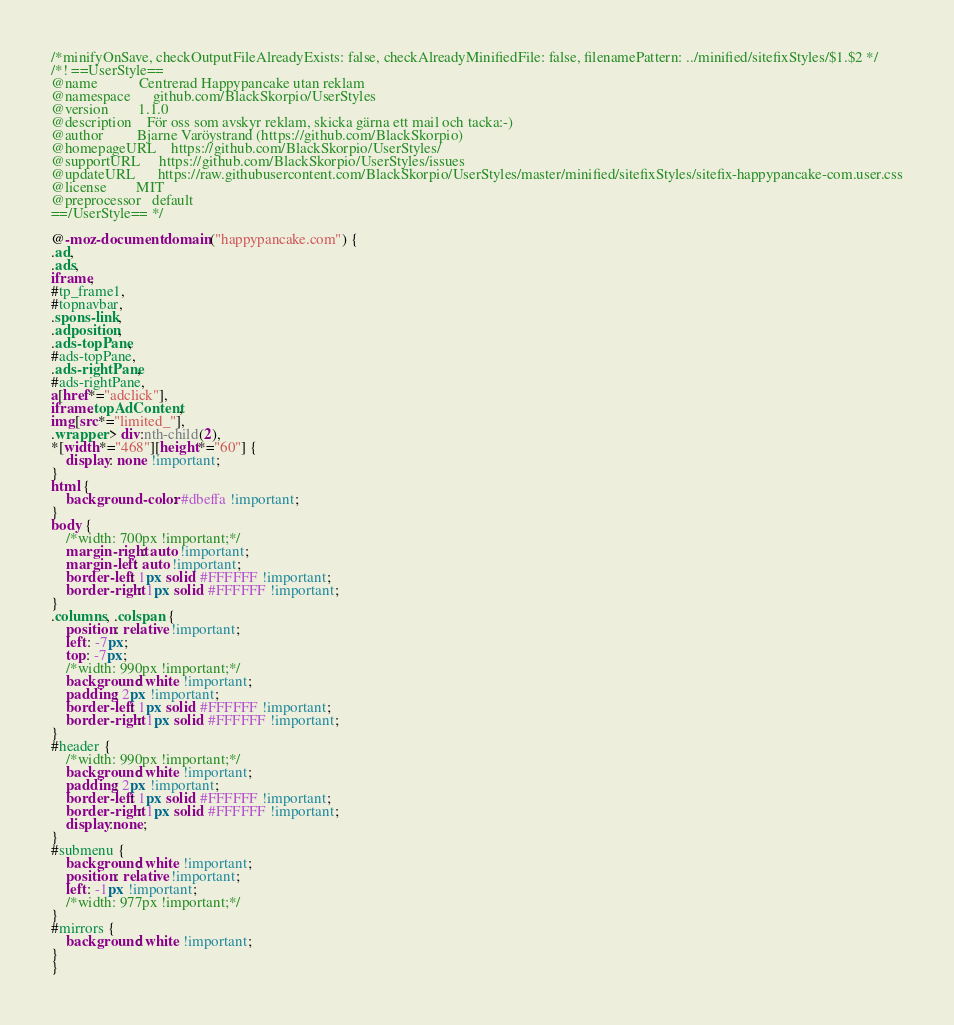<code> <loc_0><loc_0><loc_500><loc_500><_CSS_>/*minifyOnSave, checkOutputFileAlreadyExists: false, checkAlreadyMinifiedFile: false, filenamePattern: ../minified/sitefixStyles/$1.$2 */
/*! ==UserStyle==
@name			Centrerad Happypancake utan reklam
@namespace		github.com/BlackSkorpio/UserStyles
@version		1.1.0
@description	För oss som avskyr reklam, skicka gärna ett mail och tacka:-)
@author			Bjarne Varöystrand (https://github.com/BlackSkorpio)
@homepageURL	https://github.com/BlackSkorpio/UserStyles/
@supportURL		https://github.com/BlackSkorpio/UserStyles/issues
@updateURL		https://raw.githubusercontent.com/BlackSkorpio/UserStyles/master/minified/sitefixStyles/sitefix-happypancake-com.user.css
@license		MIT
@preprocessor	default
==/UserStyle== */

@-moz-document domain("happypancake.com") {
.ad,
.ads,
iframe,
#tp_frame1,
#topnavbar,
.spons-link,
.adposition,
.ads-topPane,
#ads-topPane,
.ads-rightPane,
#ads-rightPane,
a[href*="adclick"],
iframe.topAdContent,
img[src*="limited_"],
.wrapper > div:nth-child(2),
*[width*="468"][height*="60"] {
	display: none !important;
}
html {
	background-color: #dbeffa !important;
}
body {
	/*width: 700px !important;*/
	margin-right: auto !important;
	margin-left: auto !important;
	border-left: 1px solid #FFFFFF !important;
	border-right: 1px solid #FFFFFF !important;
}
.columns, .colspan {
	position: relative !important;
	left: -7px;
	top: -7px;
	/*width: 990px !important;*/
	background: white !important;
	padding: 2px !important;
	border-left: 1px solid #FFFFFF !important;
	border-right: 1px solid #FFFFFF !important;
}
#header {
	/*width: 990px !important;*/
	background: white !important;
	padding: 2px !important;
	border-left: 1px solid #FFFFFF !important;
	border-right: 1px solid #FFFFFF !important;
	display:none;
}
#submenu {
	background: white !important;
	position: relative !important;
	left: -1px !important;
	/*width: 977px !important;*/
}
#mirrors {
	background: white !important;
}
}
</code> 